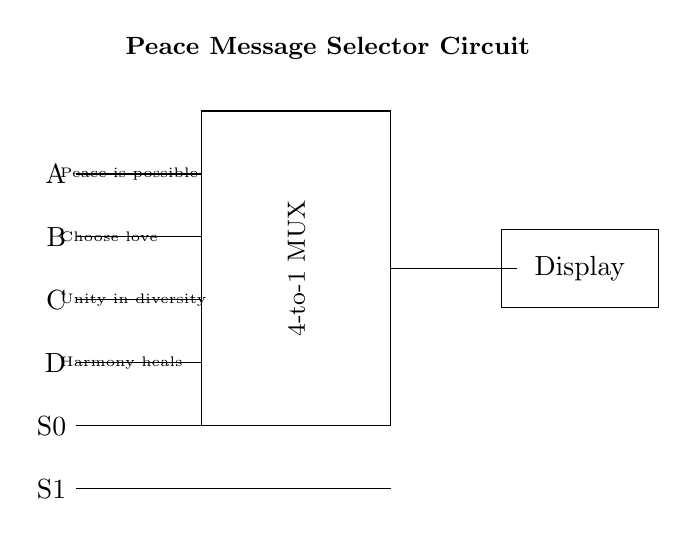What is the purpose of the 4-to-1 multiplexer in this circuit? The 4-to-1 multiplexer is used to select one of the four input peace messages (A, B, C, D) based on the selectors S0 and S1 and display the chosen message on the electronic billboard.
Answer: To select one peace message How many input lines are there in this circuit? There are four input lines labeled A, B, C, and D that each represent a different peace message that can be selected for display.
Answer: Four What messages are displayed by the input lines? The input lines correspond to the messages: "Peace is possible," "Choose love," "Unity in diversity," and "Harmony heals." Each corresponds to a specific input line where A is the first and D is the last.
Answer: Four messages How many selector lines does the multiplexer have? The multiplexer has two selector lines (S0 and S1) which are used to choose among the four input messages.
Answer: Two Which message is displayed if S0 and S1 are both low (0)? If both S0 and S1 are low (0), the output will correspond to input line A, which is the message "Peace is possible." Thus, A is selected when both selectors are at the low state.
Answer: Peace is possible What is the function of the electronic display? The electronic display shows the message selected by the multiplexer at any given time based on the states of the selector lines S0 and S1. It translates the selected input into a visible format.
Answer: Show message 